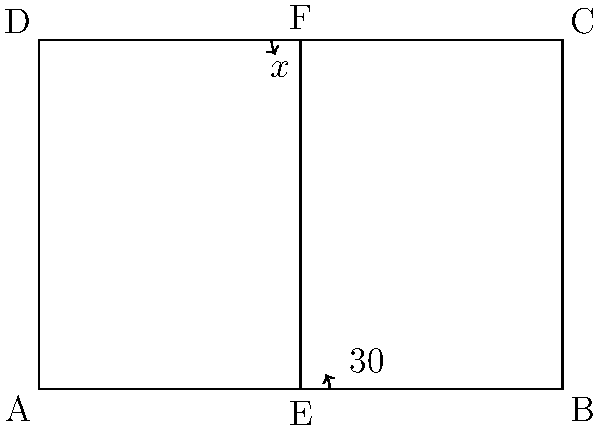In setting up the volleyball court for a match, you notice that the angle formed by the net post and the floor is 30°. If this angle and the angle at the top of the net post are complementary, what is the measure of the angle at the top of the net post (marked as $x°$ in the diagram)? To solve this problem, let's follow these steps:

1) Recall that complementary angles are two angles that add up to 90°.

2) We are given that the angle at the bottom of the net post is 30°.

3) Let the angle at the top of the net post be $x°$.

4) Since these angles are complementary, we can set up the equation:

   $30° + x° = 90°$

5) To solve for $x$, subtract 30° from both sides:

   $x° = 90° - 30°$

6) Simplify:

   $x° = 60°$

Therefore, the angle at the top of the net post is 60°.
Answer: 60° 